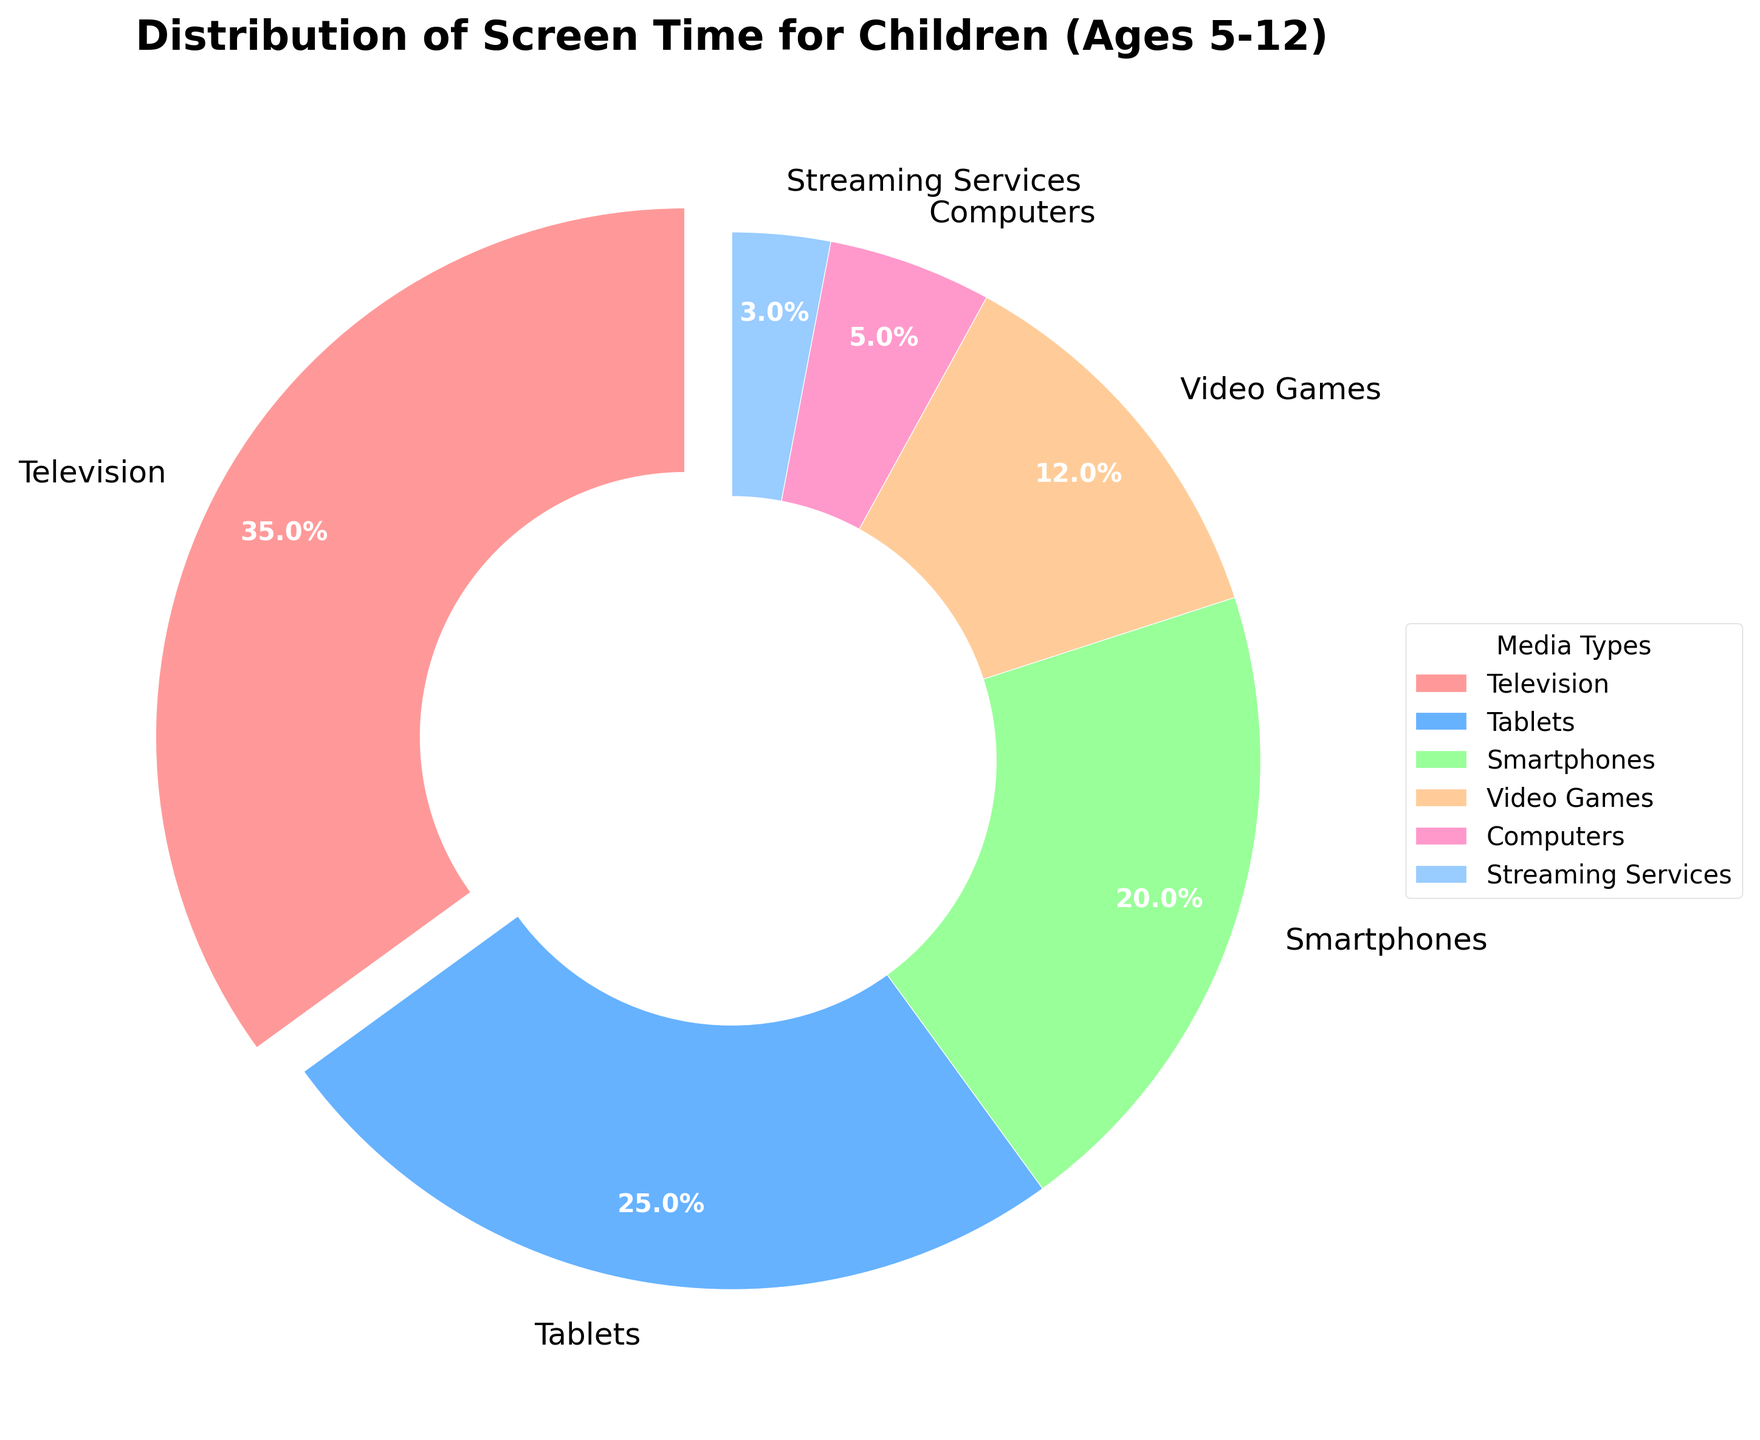Which media type has the highest percentage of screen time? The wedge with the label "Television" appears the largest and has the highest percentage shown as 35%.
Answer: Television What is the total percentage of screen time for tablets, smartphones, and video games combined? Tablets have 25%, smartphones have 20%, and video games have 12%. Sum them up as 25 + 20 + 12 = 57%.
Answer: 57% Are there any media types with less screen time than computers? Streaming services have less screen time (3%) compared to computers (5%).
Answer: Yes, streaming services Which media types have more screen time than video games? Televisions have 35%, tablets have 25%, and smartphones have 20%. These are all greater than video games, which has 12%.
Answer: Television, Tablets, Smartphones What is the difference in screen time between the most and least used media types? The most used media type is television at 35%, and the least used is streaming services at 3%. The difference is 35 - 3 = 32%.
Answer: 32% Which media type is represented by the light brown-colored wedge? The light brown wedge represents tablets, as indicated in the legend and the figure.
Answer: Tablets What percentage of screen time do computers and streaming services together account for? Computers have 5%, and streaming services have 3%. Sum them up as 5 + 3 = 8%.
Answer: 8% How does the screen time for smartphones compare to video games? Smartphones have 20% screen time and video games have 12%. Smartphones have more screen time than video games.
Answer: Smartphones have more What is the average percentage of screen time for all media types? The percentages are 35, 25, 20, 12, 5, and 3. Sum them up to get 35 + 25 + 20 + 12 + 5 + 3 = 100. There are 6 media types. The average is 100 / 6 ≈ 16.67%.
Answer: 16.67% What fraction of the screen time is dedicated to devices other than television? Television has 35%, so other devices have 100 - 35 = 65%.
Answer: 65% 